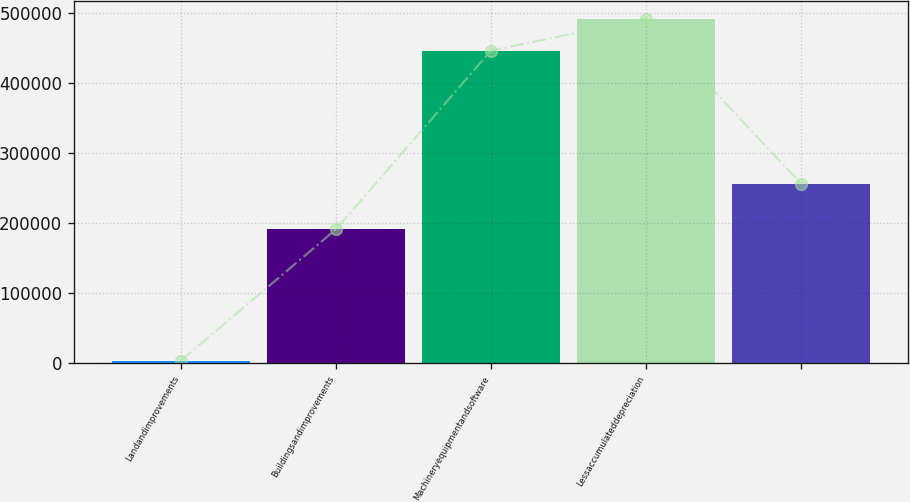Convert chart to OTSL. <chart><loc_0><loc_0><loc_500><loc_500><bar_chart><fcel>Landandimprovements<fcel>Buildingsandimprovements<fcel>Machineryequipmentandsoftware<fcel>Lessaccumulateddepreciation<fcel>Unnamed: 4<nl><fcel>3243<fcel>191096<fcel>446628<fcel>492575<fcel>256473<nl></chart> 